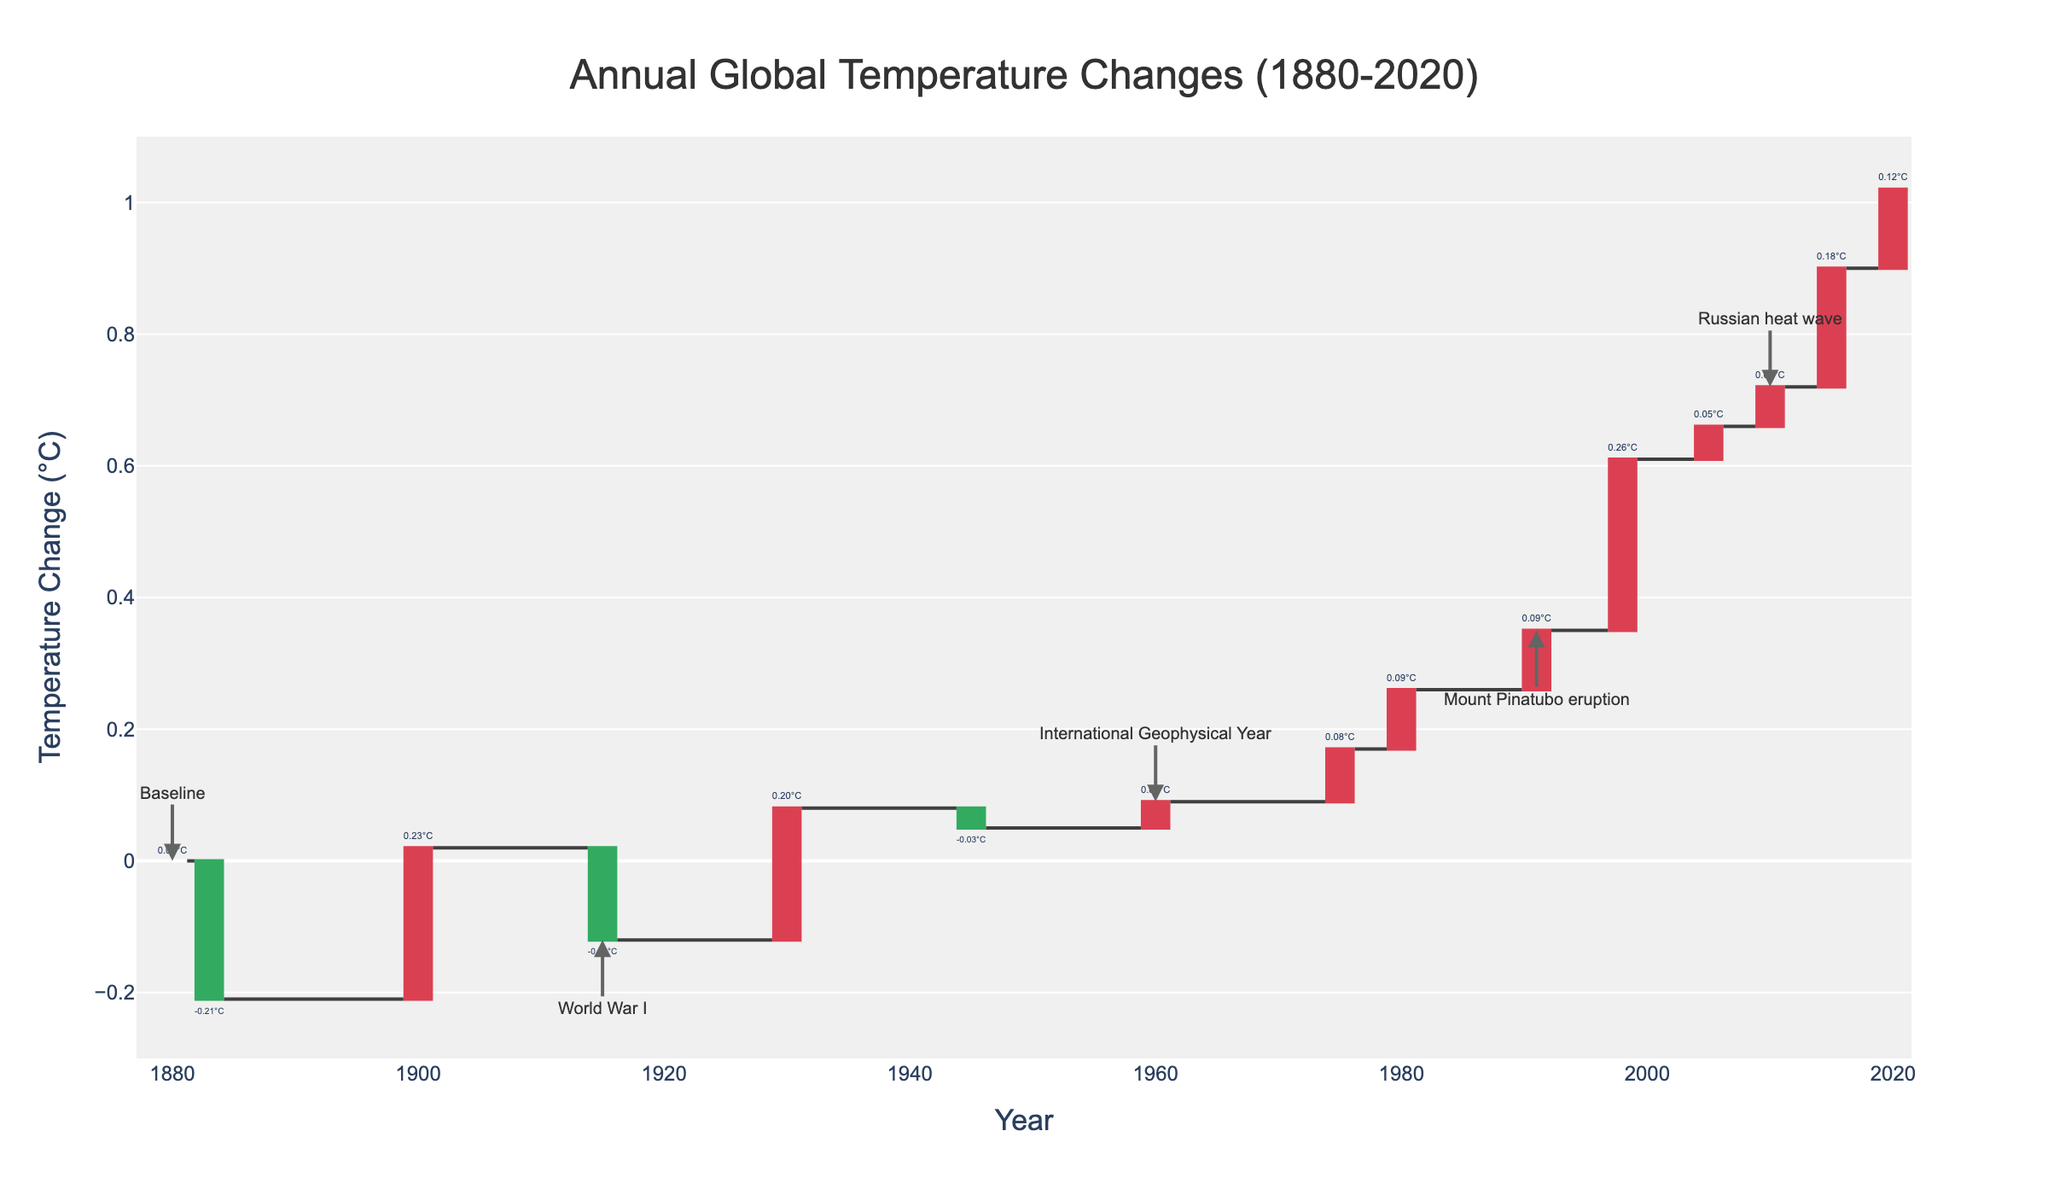What's the title of the chart? The title is located at the top center of the chart. It summarizes the data being presented. The title is "Annual Global Temperature Changes (1880-2020)".
Answer: Annual Global Temperature Changes (1880-2020) What is the temperature change in 1998, and what event is associated with it? To find this information, look at the year 1998 on the x-axis and observe the corresponding bar. The hover text provides more details, showing the temperature change and event. In 1998, the temperature change was 0.61°C, associated with a Strong El Niño.
Answer: 0.61°C, Strong El Niño Which year had the highest positive temperature change and what was the value? Scan the y-axis for the highest bar above zero and check the corresponding year on the x-axis. The highest positive temperature change occurred in 2020, with a value of 1.02°C.
Answer: 2020, 1.02°C How did the Mount Pinatubo eruption in 1991 affect the temperature? Locate the year 1991 on the x-axis and find the temperature change associated with the Mount Pinatubo eruption. The hover text indicates the event's impact on temperature. The Mount Pinatubo eruption led to a temporary global cooling with a temperature change of 0.35°C.
Answer: Temporary global cooling, 0.35°C What were the temperature changes in 1883 and 2020, and how do they compare? Look at the bars for both 1883 and 2020 on the x-axis and note their temperature changes. Compare these values directly: 1883 had a cooling of -0.21°C due to the Krakatoa Eruption, and 2020 had a warming of 1.02°C.
Answer: -0.21°C in 1883, 1.02°C in 2020 How did the COVID-19 pandemic in 2020 affect global temperature changes? Find the year 2020 on the x-axis. The hover text and the highest bar indicate that the temperature change was 1.02°C. The COVID-19 pandemic temporarily reduced emissions, but the overall temperature change continued to increase.
Answer: Temporary emissions reduction, 1.02°C What was the temperature change trend from 1945 to 1960 and what events are associated? Observe the bars from 1945 to 1960. 1945 shows a change of 0.05°C, and 1960 shows 0.09°C, indicating a rising trend. The events associated are the end of World War II with post-war industrial boom and the International Geophysical Year with increased climate research.
Answer: Increasing trend, 0.05°C (1945) to 0.09°C (1960), World War II ends, International Geophysical Year What caused the temporary global cooling in 1991, and how significant was the temperature change? Check the year 1991 on the x-axis and use the hover text to identify the event and temperature change. The Mount Pinatubo eruption caused temporary global cooling with a temperature change of 0.35°C.
Answer: Mount Pinatubo eruption, 0.35°C What are the major global climate events and their impacts on temperature in this chart? Key events include the Krakatoa Eruption (cooling), Industrial Revolution peak (CO2 emissions increase), World Wars (reduced/booming industrial activity), Dust Bowl (drought in North America), El Niño (warming), and the Paris Agreement (global climate action).
Answer: Krakatoa Eruption (cooling), Industrial Revolution peak (emissions increase), World Wars (industrial activity), Dust Bowl (drought), El Niño (warming), Paris Agreement (climate action) 